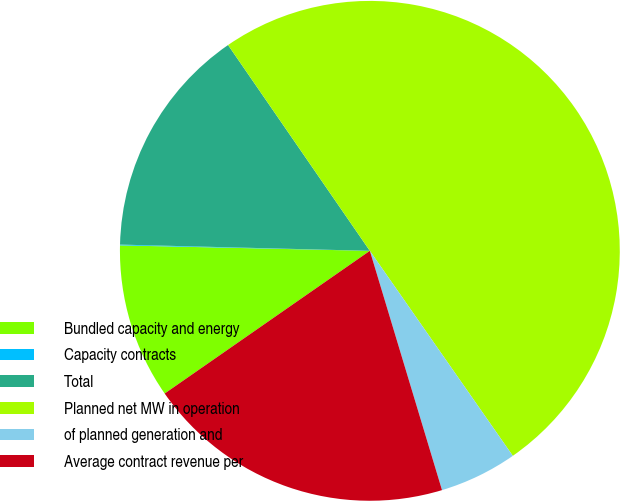Convert chart to OTSL. <chart><loc_0><loc_0><loc_500><loc_500><pie_chart><fcel>Bundled capacity and energy<fcel>Capacity contracts<fcel>Total<fcel>Planned net MW in operation<fcel>of planned generation and<fcel>Average contract revenue per<nl><fcel>10.02%<fcel>0.05%<fcel>15.0%<fcel>49.91%<fcel>5.03%<fcel>19.99%<nl></chart> 